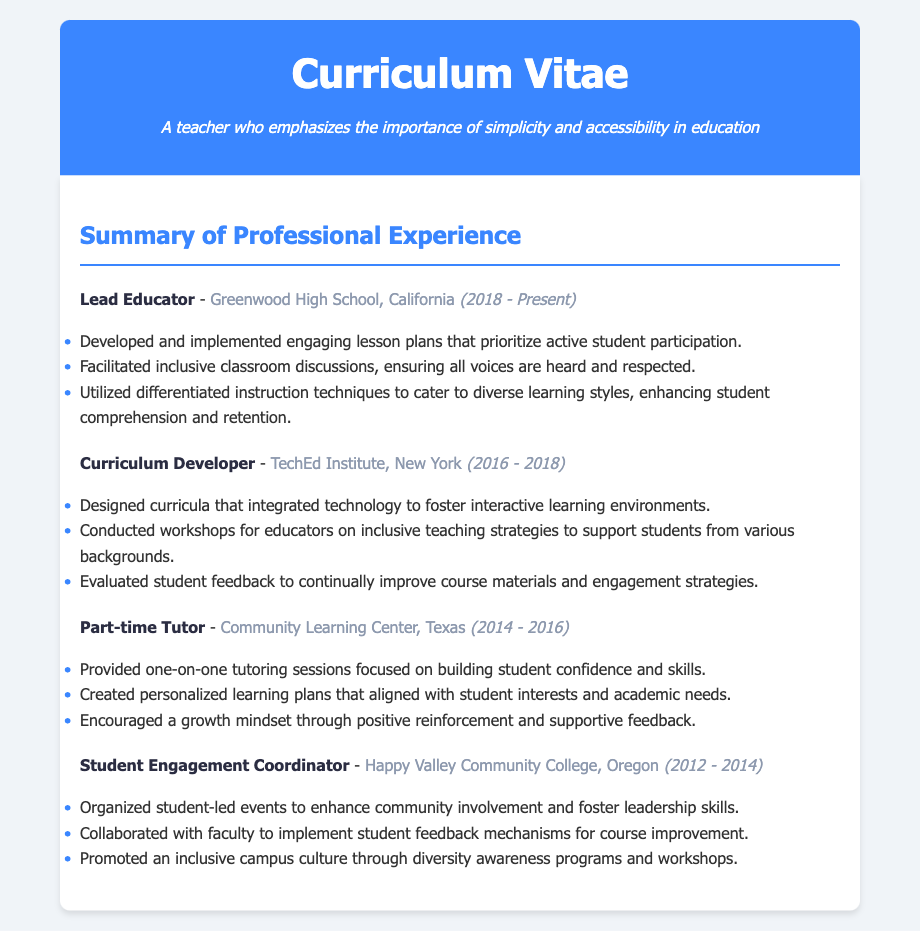What is the current position held? The current position is the most recent role listed, which is Lead Educator.
Answer: Lead Educator Which institution does the current position belong to? The institution associated with the current position is mentioned after the title and is Greenwood High School.
Answer: Greenwood High School What years did the Lead Educator serve at Greenwood High School? The years are specified in parentheses next to the position, indicating the period from 2018 to the present.
Answer: 2018 - Present How many roles are listed in the Summary of Professional Experience? The count of distinct experiences is derived by counting the number of separate experience sections in the document, which totals four.
Answer: Four What teaching strategy was emphasized in the Lead Educator role? The strategy highlighted relates to student participation as noted in the development of lesson plans.
Answer: Active student participation In which role did the individual work as a Curriculum Developer? The role of Curriculum Developer is specified under TechEd Institute in New York.
Answer: TechEd Institute How did the Student Engagement Coordinator promote inclusivity? Inclusivity was promoted through diversity awareness programs according to the details listed.
Answer: Diversity awareness programs What is a key focus of the Part-time Tutor position? The key focus is reflected in building student confidence and skills as mentioned in the responsibilities.
Answer: Building student confidence and skills What type of events did the Student Engagement Coordinator organize? The events organized were specifically student-led events, as stated in the document.
Answer: Student-led events 